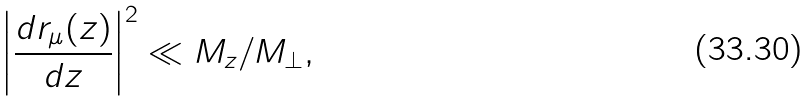Convert formula to latex. <formula><loc_0><loc_0><loc_500><loc_500>\left | \frac { d { r } _ { \mu } ( z ) } { d z } \right | ^ { 2 } \ll M _ { z } / M _ { \perp } ,</formula> 